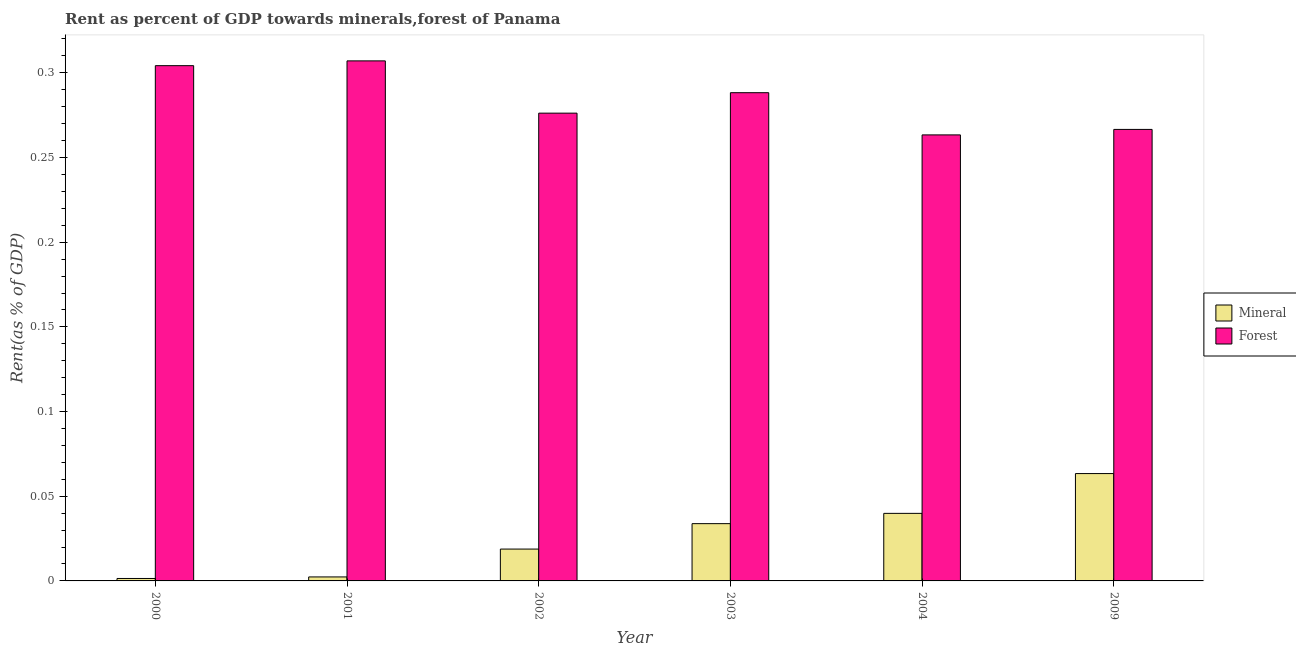How many different coloured bars are there?
Your answer should be compact. 2. Are the number of bars per tick equal to the number of legend labels?
Provide a short and direct response. Yes. Are the number of bars on each tick of the X-axis equal?
Offer a terse response. Yes. What is the forest rent in 2000?
Keep it short and to the point. 0.3. Across all years, what is the maximum mineral rent?
Offer a very short reply. 0.06. Across all years, what is the minimum forest rent?
Keep it short and to the point. 0.26. In which year was the mineral rent maximum?
Provide a short and direct response. 2009. In which year was the mineral rent minimum?
Offer a very short reply. 2000. What is the total forest rent in the graph?
Make the answer very short. 1.71. What is the difference between the forest rent in 2001 and that in 2003?
Offer a terse response. 0.02. What is the difference between the forest rent in 2000 and the mineral rent in 2003?
Offer a very short reply. 0.02. What is the average forest rent per year?
Offer a terse response. 0.28. In how many years, is the forest rent greater than 0.22 %?
Give a very brief answer. 6. What is the ratio of the mineral rent in 2004 to that in 2009?
Offer a very short reply. 0.63. Is the difference between the mineral rent in 2003 and 2004 greater than the difference between the forest rent in 2003 and 2004?
Your answer should be very brief. No. What is the difference between the highest and the second highest forest rent?
Your answer should be compact. 0. What is the difference between the highest and the lowest forest rent?
Offer a terse response. 0.04. In how many years, is the mineral rent greater than the average mineral rent taken over all years?
Make the answer very short. 3. Is the sum of the mineral rent in 2001 and 2004 greater than the maximum forest rent across all years?
Make the answer very short. No. What does the 1st bar from the left in 2009 represents?
Make the answer very short. Mineral. What does the 1st bar from the right in 2004 represents?
Offer a terse response. Forest. Are all the bars in the graph horizontal?
Keep it short and to the point. No. How many years are there in the graph?
Your answer should be compact. 6. Are the values on the major ticks of Y-axis written in scientific E-notation?
Your answer should be compact. No. Does the graph contain grids?
Ensure brevity in your answer.  No. Where does the legend appear in the graph?
Give a very brief answer. Center right. How are the legend labels stacked?
Make the answer very short. Vertical. What is the title of the graph?
Provide a succinct answer. Rent as percent of GDP towards minerals,forest of Panama. Does "current US$" appear as one of the legend labels in the graph?
Keep it short and to the point. No. What is the label or title of the Y-axis?
Your answer should be very brief. Rent(as % of GDP). What is the Rent(as % of GDP) in Mineral in 2000?
Make the answer very short. 0. What is the Rent(as % of GDP) in Forest in 2000?
Make the answer very short. 0.3. What is the Rent(as % of GDP) of Mineral in 2001?
Your answer should be very brief. 0. What is the Rent(as % of GDP) of Forest in 2001?
Offer a very short reply. 0.31. What is the Rent(as % of GDP) of Mineral in 2002?
Offer a very short reply. 0.02. What is the Rent(as % of GDP) in Forest in 2002?
Make the answer very short. 0.28. What is the Rent(as % of GDP) in Mineral in 2003?
Your response must be concise. 0.03. What is the Rent(as % of GDP) of Forest in 2003?
Make the answer very short. 0.29. What is the Rent(as % of GDP) in Mineral in 2004?
Provide a succinct answer. 0.04. What is the Rent(as % of GDP) of Forest in 2004?
Your response must be concise. 0.26. What is the Rent(as % of GDP) of Mineral in 2009?
Offer a very short reply. 0.06. What is the Rent(as % of GDP) in Forest in 2009?
Ensure brevity in your answer.  0.27. Across all years, what is the maximum Rent(as % of GDP) of Mineral?
Ensure brevity in your answer.  0.06. Across all years, what is the maximum Rent(as % of GDP) of Forest?
Provide a short and direct response. 0.31. Across all years, what is the minimum Rent(as % of GDP) in Mineral?
Offer a very short reply. 0. Across all years, what is the minimum Rent(as % of GDP) of Forest?
Your answer should be very brief. 0.26. What is the total Rent(as % of GDP) of Mineral in the graph?
Make the answer very short. 0.16. What is the total Rent(as % of GDP) in Forest in the graph?
Your response must be concise. 1.71. What is the difference between the Rent(as % of GDP) in Mineral in 2000 and that in 2001?
Make the answer very short. -0. What is the difference between the Rent(as % of GDP) in Forest in 2000 and that in 2001?
Your answer should be very brief. -0. What is the difference between the Rent(as % of GDP) of Mineral in 2000 and that in 2002?
Make the answer very short. -0.02. What is the difference between the Rent(as % of GDP) in Forest in 2000 and that in 2002?
Ensure brevity in your answer.  0.03. What is the difference between the Rent(as % of GDP) of Mineral in 2000 and that in 2003?
Offer a very short reply. -0.03. What is the difference between the Rent(as % of GDP) in Forest in 2000 and that in 2003?
Offer a very short reply. 0.02. What is the difference between the Rent(as % of GDP) in Mineral in 2000 and that in 2004?
Keep it short and to the point. -0.04. What is the difference between the Rent(as % of GDP) of Forest in 2000 and that in 2004?
Your answer should be compact. 0.04. What is the difference between the Rent(as % of GDP) of Mineral in 2000 and that in 2009?
Provide a succinct answer. -0.06. What is the difference between the Rent(as % of GDP) in Forest in 2000 and that in 2009?
Provide a succinct answer. 0.04. What is the difference between the Rent(as % of GDP) of Mineral in 2001 and that in 2002?
Give a very brief answer. -0.02. What is the difference between the Rent(as % of GDP) of Forest in 2001 and that in 2002?
Keep it short and to the point. 0.03. What is the difference between the Rent(as % of GDP) in Mineral in 2001 and that in 2003?
Offer a very short reply. -0.03. What is the difference between the Rent(as % of GDP) of Forest in 2001 and that in 2003?
Offer a very short reply. 0.02. What is the difference between the Rent(as % of GDP) of Mineral in 2001 and that in 2004?
Provide a short and direct response. -0.04. What is the difference between the Rent(as % of GDP) in Forest in 2001 and that in 2004?
Offer a terse response. 0.04. What is the difference between the Rent(as % of GDP) in Mineral in 2001 and that in 2009?
Provide a succinct answer. -0.06. What is the difference between the Rent(as % of GDP) of Forest in 2001 and that in 2009?
Offer a very short reply. 0.04. What is the difference between the Rent(as % of GDP) of Mineral in 2002 and that in 2003?
Your response must be concise. -0.01. What is the difference between the Rent(as % of GDP) in Forest in 2002 and that in 2003?
Give a very brief answer. -0.01. What is the difference between the Rent(as % of GDP) of Mineral in 2002 and that in 2004?
Your response must be concise. -0.02. What is the difference between the Rent(as % of GDP) of Forest in 2002 and that in 2004?
Ensure brevity in your answer.  0.01. What is the difference between the Rent(as % of GDP) in Mineral in 2002 and that in 2009?
Offer a very short reply. -0.04. What is the difference between the Rent(as % of GDP) of Forest in 2002 and that in 2009?
Your answer should be compact. 0.01. What is the difference between the Rent(as % of GDP) in Mineral in 2003 and that in 2004?
Your answer should be compact. -0.01. What is the difference between the Rent(as % of GDP) in Forest in 2003 and that in 2004?
Your response must be concise. 0.02. What is the difference between the Rent(as % of GDP) of Mineral in 2003 and that in 2009?
Provide a short and direct response. -0.03. What is the difference between the Rent(as % of GDP) in Forest in 2003 and that in 2009?
Offer a very short reply. 0.02. What is the difference between the Rent(as % of GDP) of Mineral in 2004 and that in 2009?
Make the answer very short. -0.02. What is the difference between the Rent(as % of GDP) in Forest in 2004 and that in 2009?
Your response must be concise. -0. What is the difference between the Rent(as % of GDP) in Mineral in 2000 and the Rent(as % of GDP) in Forest in 2001?
Your response must be concise. -0.31. What is the difference between the Rent(as % of GDP) in Mineral in 2000 and the Rent(as % of GDP) in Forest in 2002?
Provide a short and direct response. -0.27. What is the difference between the Rent(as % of GDP) of Mineral in 2000 and the Rent(as % of GDP) of Forest in 2003?
Your response must be concise. -0.29. What is the difference between the Rent(as % of GDP) in Mineral in 2000 and the Rent(as % of GDP) in Forest in 2004?
Provide a succinct answer. -0.26. What is the difference between the Rent(as % of GDP) in Mineral in 2000 and the Rent(as % of GDP) in Forest in 2009?
Provide a short and direct response. -0.27. What is the difference between the Rent(as % of GDP) in Mineral in 2001 and the Rent(as % of GDP) in Forest in 2002?
Offer a terse response. -0.27. What is the difference between the Rent(as % of GDP) in Mineral in 2001 and the Rent(as % of GDP) in Forest in 2003?
Offer a terse response. -0.29. What is the difference between the Rent(as % of GDP) in Mineral in 2001 and the Rent(as % of GDP) in Forest in 2004?
Offer a terse response. -0.26. What is the difference between the Rent(as % of GDP) in Mineral in 2001 and the Rent(as % of GDP) in Forest in 2009?
Provide a short and direct response. -0.26. What is the difference between the Rent(as % of GDP) in Mineral in 2002 and the Rent(as % of GDP) in Forest in 2003?
Make the answer very short. -0.27. What is the difference between the Rent(as % of GDP) of Mineral in 2002 and the Rent(as % of GDP) of Forest in 2004?
Keep it short and to the point. -0.24. What is the difference between the Rent(as % of GDP) in Mineral in 2002 and the Rent(as % of GDP) in Forest in 2009?
Your answer should be compact. -0.25. What is the difference between the Rent(as % of GDP) of Mineral in 2003 and the Rent(as % of GDP) of Forest in 2004?
Offer a very short reply. -0.23. What is the difference between the Rent(as % of GDP) in Mineral in 2003 and the Rent(as % of GDP) in Forest in 2009?
Offer a very short reply. -0.23. What is the difference between the Rent(as % of GDP) of Mineral in 2004 and the Rent(as % of GDP) of Forest in 2009?
Make the answer very short. -0.23. What is the average Rent(as % of GDP) of Mineral per year?
Offer a very short reply. 0.03. What is the average Rent(as % of GDP) of Forest per year?
Make the answer very short. 0.28. In the year 2000, what is the difference between the Rent(as % of GDP) in Mineral and Rent(as % of GDP) in Forest?
Make the answer very short. -0.3. In the year 2001, what is the difference between the Rent(as % of GDP) of Mineral and Rent(as % of GDP) of Forest?
Your answer should be very brief. -0.3. In the year 2002, what is the difference between the Rent(as % of GDP) of Mineral and Rent(as % of GDP) of Forest?
Ensure brevity in your answer.  -0.26. In the year 2003, what is the difference between the Rent(as % of GDP) of Mineral and Rent(as % of GDP) of Forest?
Keep it short and to the point. -0.25. In the year 2004, what is the difference between the Rent(as % of GDP) of Mineral and Rent(as % of GDP) of Forest?
Provide a short and direct response. -0.22. In the year 2009, what is the difference between the Rent(as % of GDP) in Mineral and Rent(as % of GDP) in Forest?
Keep it short and to the point. -0.2. What is the ratio of the Rent(as % of GDP) in Mineral in 2000 to that in 2001?
Give a very brief answer. 0.61. What is the ratio of the Rent(as % of GDP) in Forest in 2000 to that in 2001?
Offer a terse response. 0.99. What is the ratio of the Rent(as % of GDP) in Mineral in 2000 to that in 2002?
Your answer should be compact. 0.08. What is the ratio of the Rent(as % of GDP) in Forest in 2000 to that in 2002?
Offer a very short reply. 1.1. What is the ratio of the Rent(as % of GDP) in Mineral in 2000 to that in 2003?
Your answer should be very brief. 0.04. What is the ratio of the Rent(as % of GDP) of Forest in 2000 to that in 2003?
Offer a terse response. 1.06. What is the ratio of the Rent(as % of GDP) of Mineral in 2000 to that in 2004?
Make the answer very short. 0.04. What is the ratio of the Rent(as % of GDP) in Forest in 2000 to that in 2004?
Keep it short and to the point. 1.16. What is the ratio of the Rent(as % of GDP) of Mineral in 2000 to that in 2009?
Make the answer very short. 0.02. What is the ratio of the Rent(as % of GDP) of Forest in 2000 to that in 2009?
Your response must be concise. 1.14. What is the ratio of the Rent(as % of GDP) in Mineral in 2001 to that in 2002?
Provide a short and direct response. 0.13. What is the ratio of the Rent(as % of GDP) of Forest in 2001 to that in 2002?
Your answer should be very brief. 1.11. What is the ratio of the Rent(as % of GDP) in Mineral in 2001 to that in 2003?
Your answer should be compact. 0.07. What is the ratio of the Rent(as % of GDP) in Forest in 2001 to that in 2003?
Provide a succinct answer. 1.07. What is the ratio of the Rent(as % of GDP) in Mineral in 2001 to that in 2004?
Provide a short and direct response. 0.06. What is the ratio of the Rent(as % of GDP) of Forest in 2001 to that in 2004?
Provide a short and direct response. 1.17. What is the ratio of the Rent(as % of GDP) of Mineral in 2001 to that in 2009?
Your response must be concise. 0.04. What is the ratio of the Rent(as % of GDP) of Forest in 2001 to that in 2009?
Give a very brief answer. 1.15. What is the ratio of the Rent(as % of GDP) in Mineral in 2002 to that in 2003?
Your answer should be compact. 0.56. What is the ratio of the Rent(as % of GDP) in Forest in 2002 to that in 2003?
Your answer should be compact. 0.96. What is the ratio of the Rent(as % of GDP) in Mineral in 2002 to that in 2004?
Your answer should be compact. 0.47. What is the ratio of the Rent(as % of GDP) in Forest in 2002 to that in 2004?
Your answer should be very brief. 1.05. What is the ratio of the Rent(as % of GDP) in Mineral in 2002 to that in 2009?
Keep it short and to the point. 0.3. What is the ratio of the Rent(as % of GDP) in Forest in 2002 to that in 2009?
Your response must be concise. 1.04. What is the ratio of the Rent(as % of GDP) in Mineral in 2003 to that in 2004?
Offer a very short reply. 0.85. What is the ratio of the Rent(as % of GDP) of Forest in 2003 to that in 2004?
Ensure brevity in your answer.  1.09. What is the ratio of the Rent(as % of GDP) of Mineral in 2003 to that in 2009?
Ensure brevity in your answer.  0.53. What is the ratio of the Rent(as % of GDP) in Forest in 2003 to that in 2009?
Keep it short and to the point. 1.08. What is the ratio of the Rent(as % of GDP) in Mineral in 2004 to that in 2009?
Ensure brevity in your answer.  0.63. What is the ratio of the Rent(as % of GDP) of Forest in 2004 to that in 2009?
Make the answer very short. 0.99. What is the difference between the highest and the second highest Rent(as % of GDP) in Mineral?
Make the answer very short. 0.02. What is the difference between the highest and the second highest Rent(as % of GDP) of Forest?
Your answer should be very brief. 0. What is the difference between the highest and the lowest Rent(as % of GDP) of Mineral?
Make the answer very short. 0.06. What is the difference between the highest and the lowest Rent(as % of GDP) in Forest?
Provide a short and direct response. 0.04. 